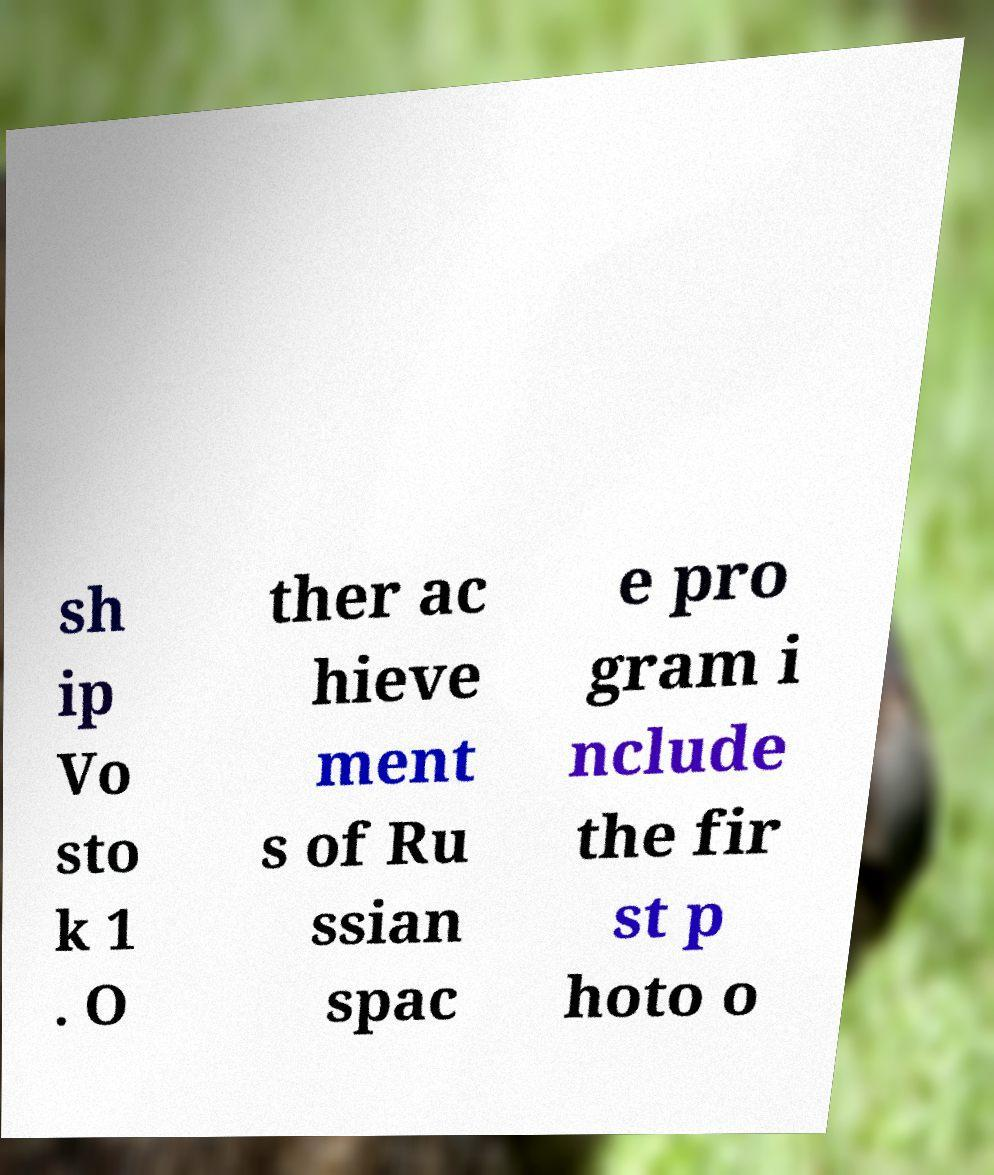Can you read and provide the text displayed in the image?This photo seems to have some interesting text. Can you extract and type it out for me? sh ip Vo sto k 1 . O ther ac hieve ment s of Ru ssian spac e pro gram i nclude the fir st p hoto o 